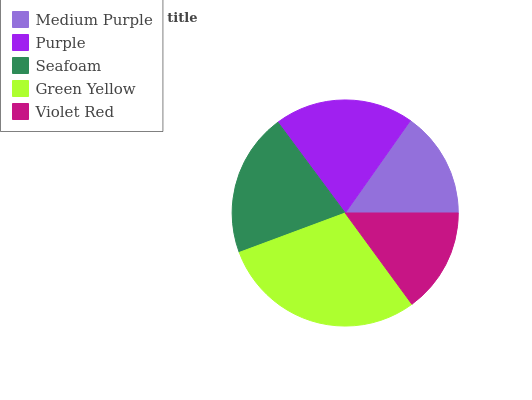Is Violet Red the minimum?
Answer yes or no. Yes. Is Green Yellow the maximum?
Answer yes or no. Yes. Is Purple the minimum?
Answer yes or no. No. Is Purple the maximum?
Answer yes or no. No. Is Purple greater than Medium Purple?
Answer yes or no. Yes. Is Medium Purple less than Purple?
Answer yes or no. Yes. Is Medium Purple greater than Purple?
Answer yes or no. No. Is Purple less than Medium Purple?
Answer yes or no. No. Is Purple the high median?
Answer yes or no. Yes. Is Purple the low median?
Answer yes or no. Yes. Is Medium Purple the high median?
Answer yes or no. No. Is Medium Purple the low median?
Answer yes or no. No. 